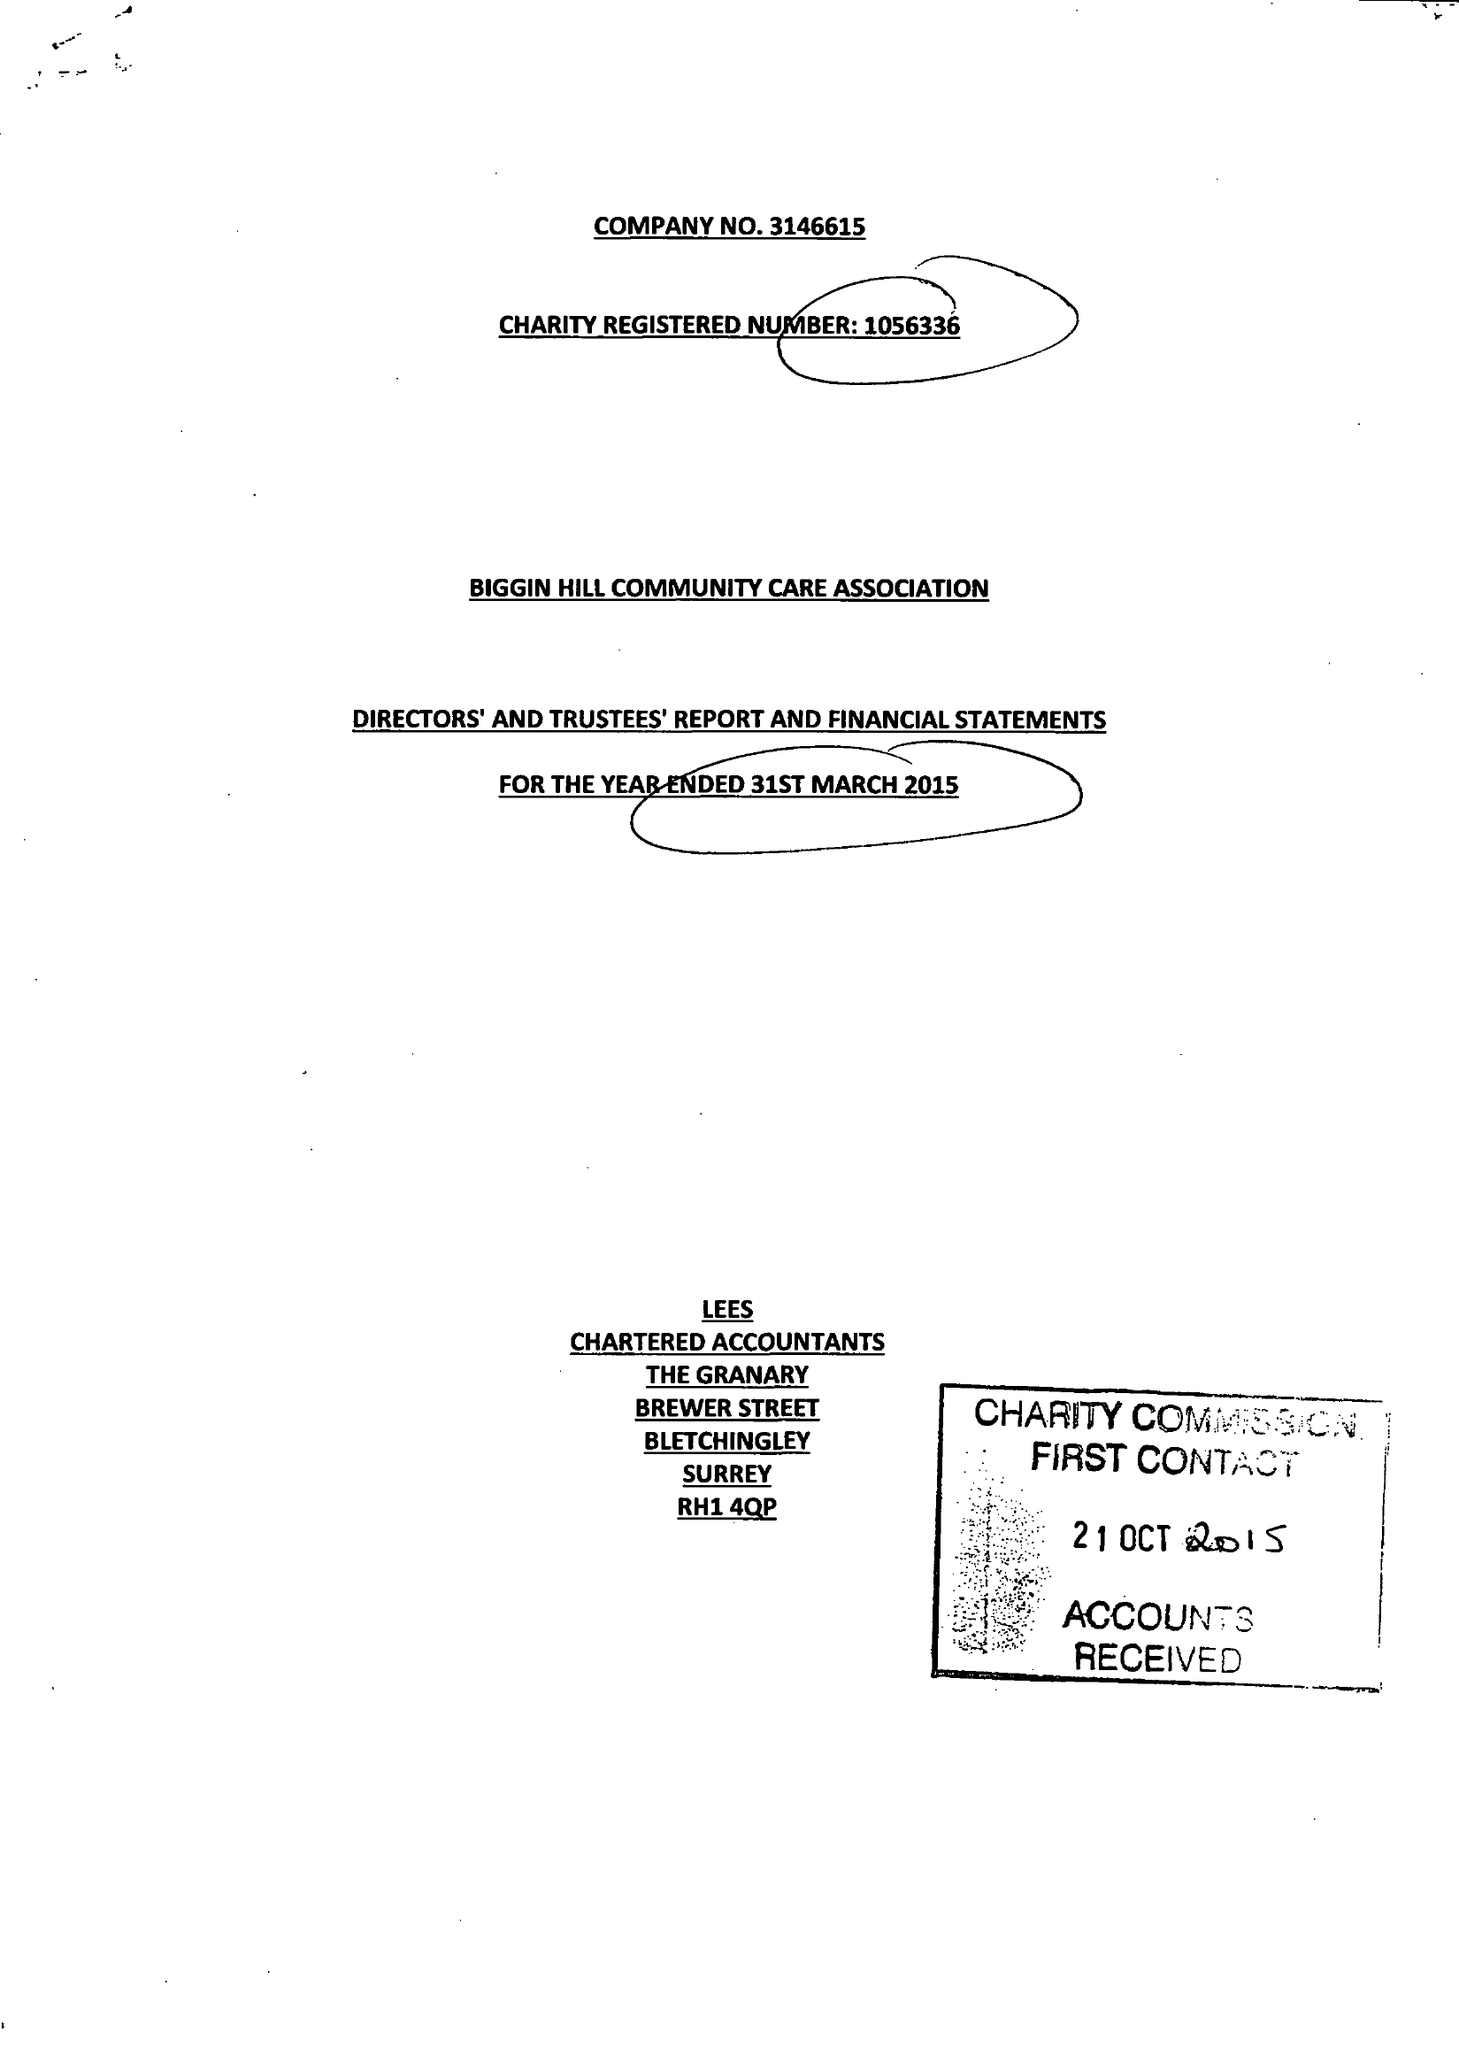What is the value for the charity_number?
Answer the question using a single word or phrase. 1056336 